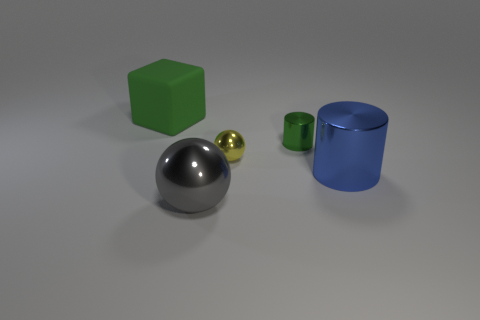Add 5 gray objects. How many objects exist? 10 Subtract all spheres. How many objects are left? 3 Add 4 large blue metallic cylinders. How many large blue metallic cylinders are left? 5 Add 2 matte things. How many matte things exist? 3 Subtract 0 purple cubes. How many objects are left? 5 Subtract all blue objects. Subtract all tiny blue blocks. How many objects are left? 4 